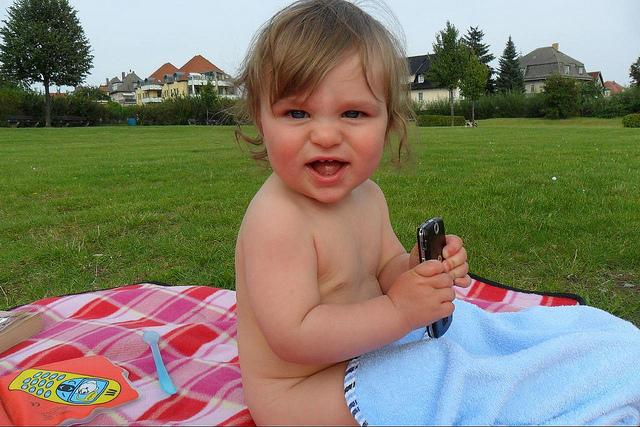What fairly important item is missing from this child?

Choices:
A) bolo tie
B) diaper
C) jeans
D) wrist bands diaper 